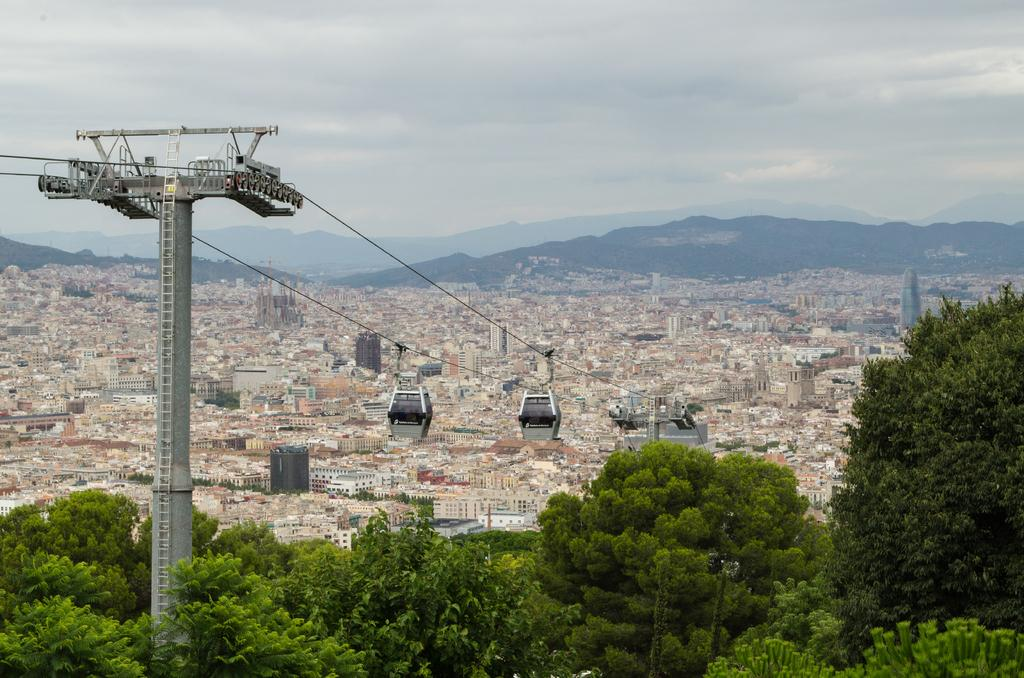What type of transportation can be seen in the image? There are ropeway trolleys in the image. What natural elements are present in the image? There are trees and hills in the image. What type of structures can be seen in the image? There are buildings and tower buildings in the image. What is visible in the sky in the image? There are clouds in the sky in the image. What type of soup is being served in the image? There is no soup present in the image. What type of cushion is used for the ropeway trolleys in the image? The image does not show any cushions associated with the ropeway trolleys. 